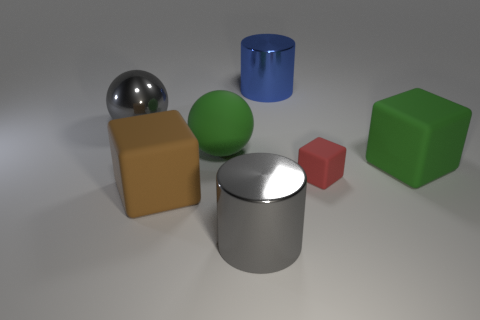Add 1 big metallic cylinders. How many objects exist? 8 Subtract all large green cubes. How many cubes are left? 2 Subtract all blue cylinders. How many cylinders are left? 1 Subtract 2 cylinders. How many cylinders are left? 0 Subtract all cylinders. How many objects are left? 5 Subtract all purple blocks. How many green balls are left? 1 Subtract all blue metal cylinders. Subtract all small red blocks. How many objects are left? 5 Add 3 tiny red matte blocks. How many tiny red matte blocks are left? 4 Add 2 big rubber objects. How many big rubber objects exist? 5 Subtract 0 purple blocks. How many objects are left? 7 